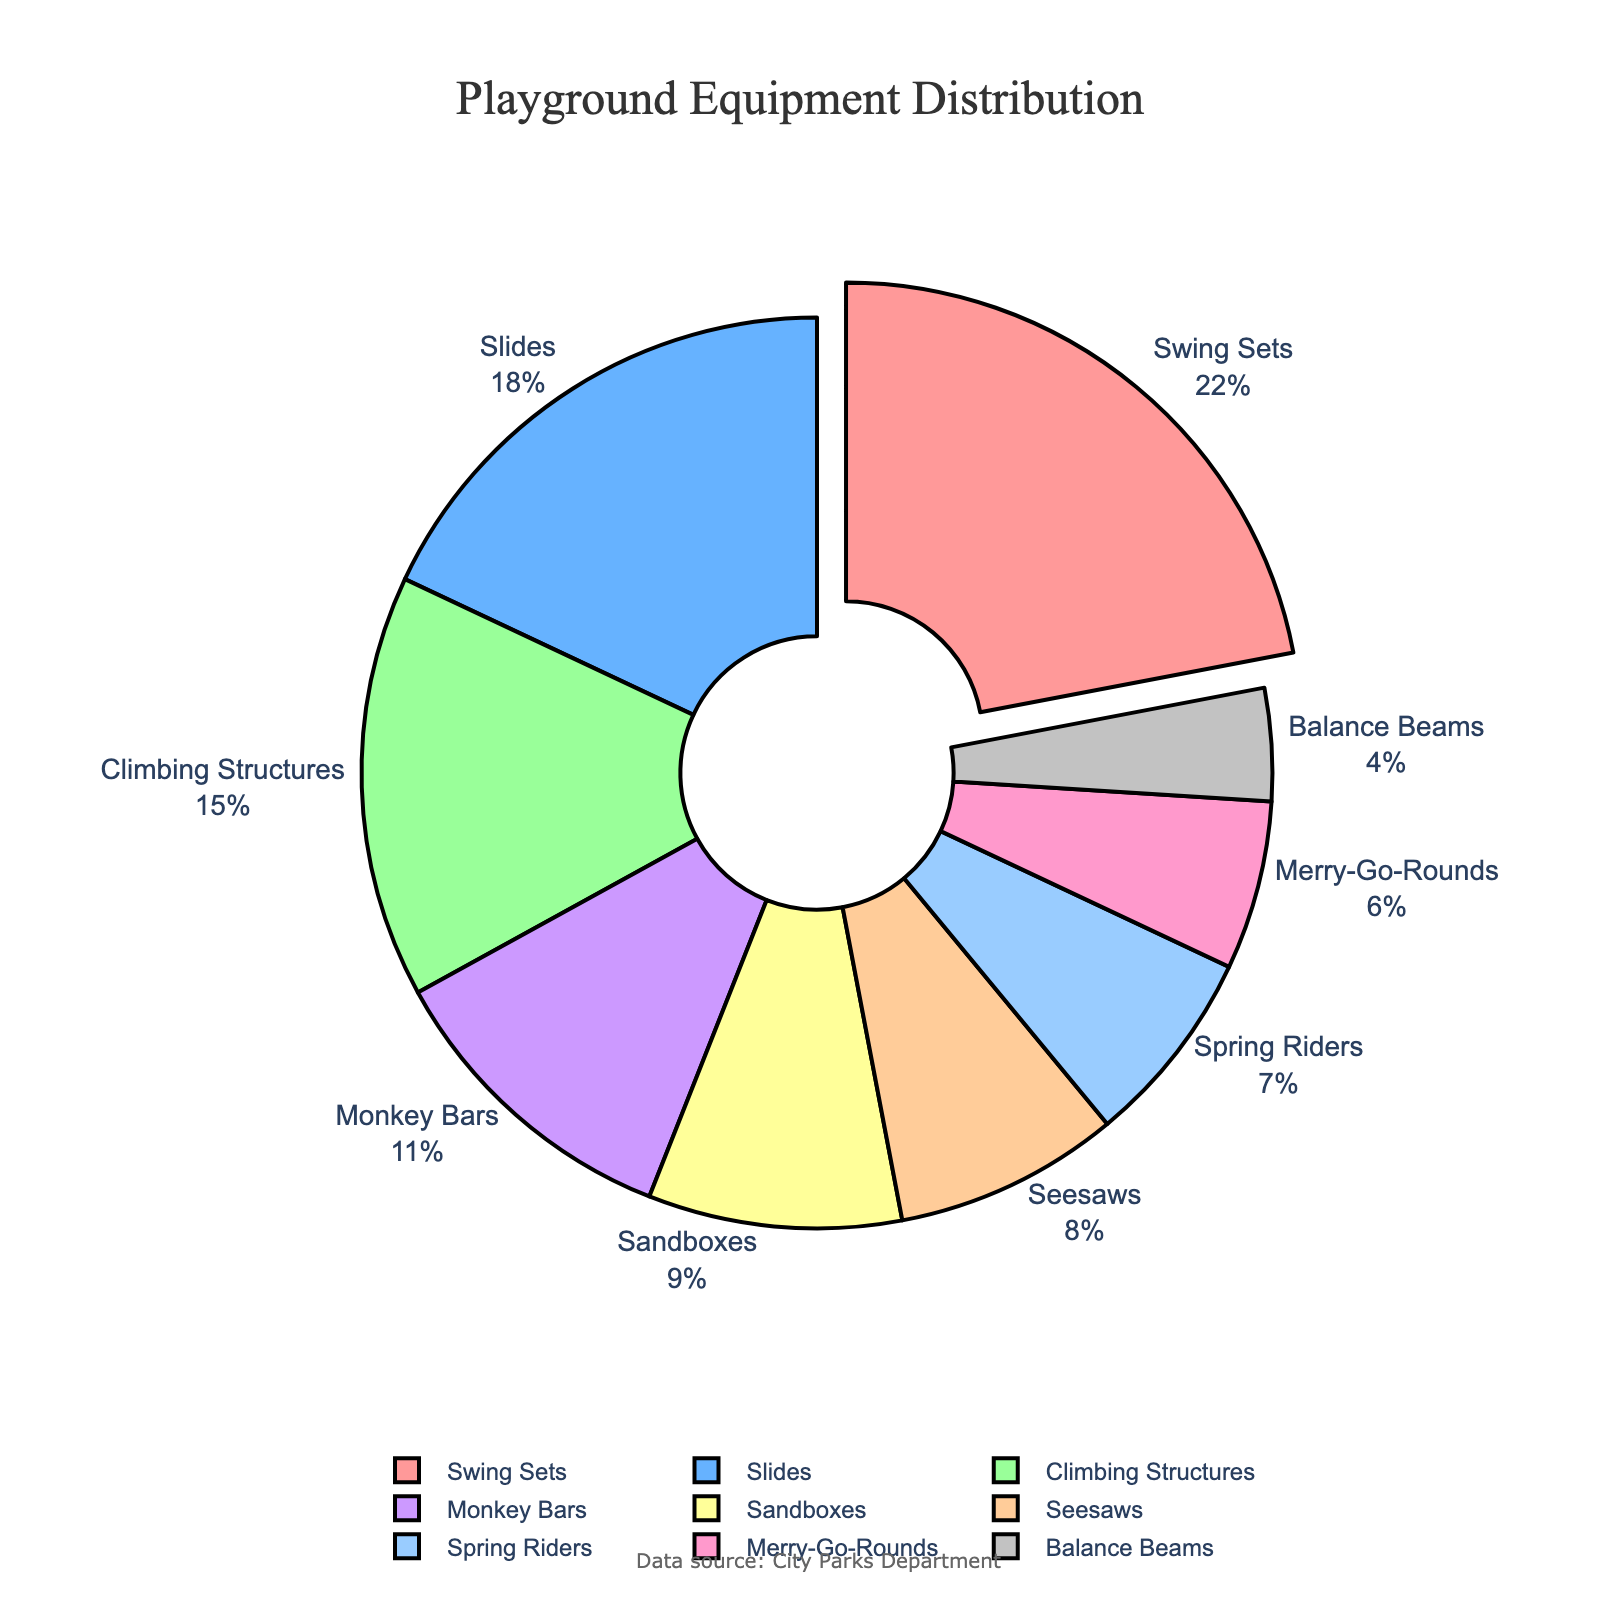Which equipment type has the highest percentage? The figure highlights the segment with the highest percentage by pulling it out from the pie chart. From the labels and percentage values given, Swing Sets have the highest percentage.
Answer: Swing Sets What is the combined percentage of Climbing Structures and Monkey Bars? From the chart, Climbing Structures account for 15% and Monkey Bars account for 11%. Adding these two percentages, \(15 + 11 = 26\%\).
Answer: 26% Which equipment type accounts for less than 5% of the total? Looking at the labels and percentages, Balance Beams has a percentage of 4%, which is less than 5%.
Answer: Balance Beams How much more percentage do Swing Sets have compared to Slides? Swing Sets have 22% and Slides have 18%. Subtract the percentage of Slides from that of Swing Sets to find the difference: \(22 - 18 = 4\%\).
Answer: 4% What is the average percentage of Sandboxes, Spring Riders, and Seesaws? The percentages for Sandboxes, Spring Riders, and Seesaws are 9%, 7%, and 8%, respectively. Add these values and divide by the number of equipment types: \((9 + 7 + 8)/3 = 8\%\).
Answer: 8% Which equipment types are represented by shades of pink in the pie chart? The pie chart uses a color scheme, and two shades of pink are used for Swing Sets and Merry-Go-Rounds.
Answer: Swing Sets, Merry-Go-Rounds How do the percentages of Seesaws and Spring Riders compare? Seesaws have 8% and Spring Riders have 7%. Since 8% is greater than 7%, Seesaws have a higher percentage.
Answer: Seesaws have a higher percentage What percentage of playground equipment does not include Swing Sets, Slides, or Climbing Structures? First, sum the percentages of Swing Sets (22%), Slides (18%), and Climbing Structures (15%): \(22 + 18 + 15 = 55\%\). Subtract this from the total: \(100 - 55 = 45\%\).
Answer: 45% Which equipment type is directly adjacent to Seesaws in the pie chart? By visually examining the pie chart segments, Seesaws are adjacent to Climbing Structures and Merry-Go-Rounds.
Answer: Climbing Structures, Merry-Go-Rounds 